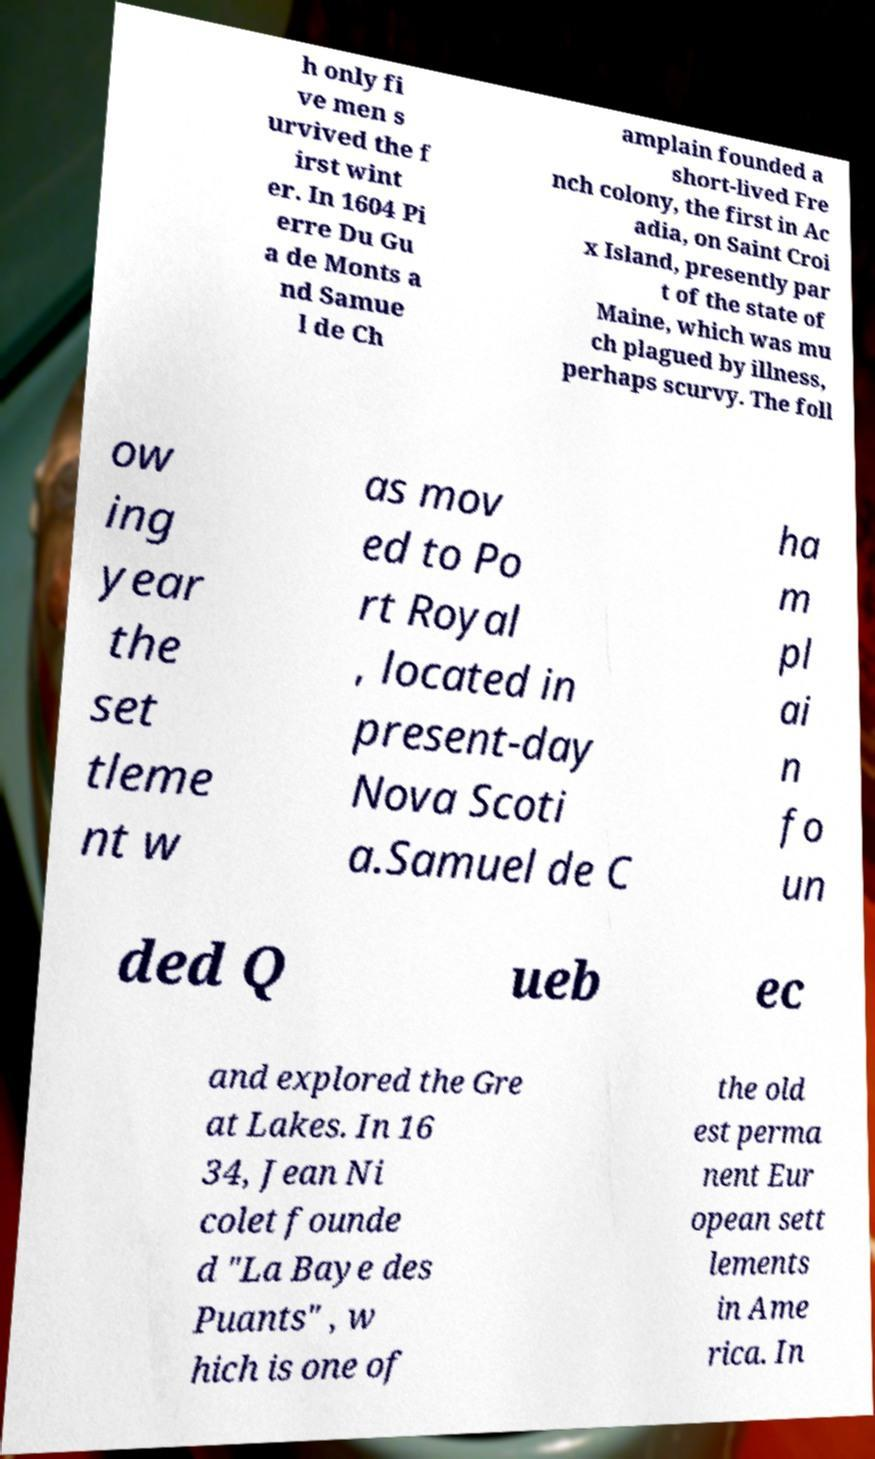I need the written content from this picture converted into text. Can you do that? h only fi ve men s urvived the f irst wint er. In 1604 Pi erre Du Gu a de Monts a nd Samue l de Ch amplain founded a short-lived Fre nch colony, the first in Ac adia, on Saint Croi x Island, presently par t of the state of Maine, which was mu ch plagued by illness, perhaps scurvy. The foll ow ing year the set tleme nt w as mov ed to Po rt Royal , located in present-day Nova Scoti a.Samuel de C ha m pl ai n fo un ded Q ueb ec and explored the Gre at Lakes. In 16 34, Jean Ni colet founde d "La Baye des Puants" , w hich is one of the old est perma nent Eur opean sett lements in Ame rica. In 